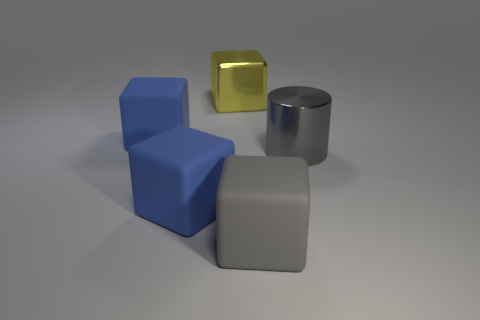How many other objects are there of the same material as the big cylinder?
Provide a short and direct response. 1. What number of big cubes are the same color as the metallic cylinder?
Keep it short and to the point. 1. There is a metallic thing that is behind the big object that is on the right side of the rubber object right of the big yellow metal block; what size is it?
Keep it short and to the point. Large. What number of rubber objects are blue blocks or big things?
Offer a terse response. 3. There is a large yellow metallic thing; does it have the same shape as the big shiny object that is right of the shiny block?
Your answer should be compact. No. Are there more big blue things right of the cylinder than large blocks on the right side of the large gray block?
Offer a very short reply. No. Is there any other thing that has the same color as the cylinder?
Make the answer very short. Yes. Are there any big blocks that are on the right side of the large blue block that is left of the blue block in front of the big gray cylinder?
Give a very brief answer. Yes. Does the big gray object that is behind the large gray rubber cube have the same shape as the large yellow metallic object?
Your answer should be compact. No. Is the number of gray rubber objects on the left side of the big gray matte thing less than the number of matte things that are behind the big gray metallic thing?
Offer a terse response. Yes. 